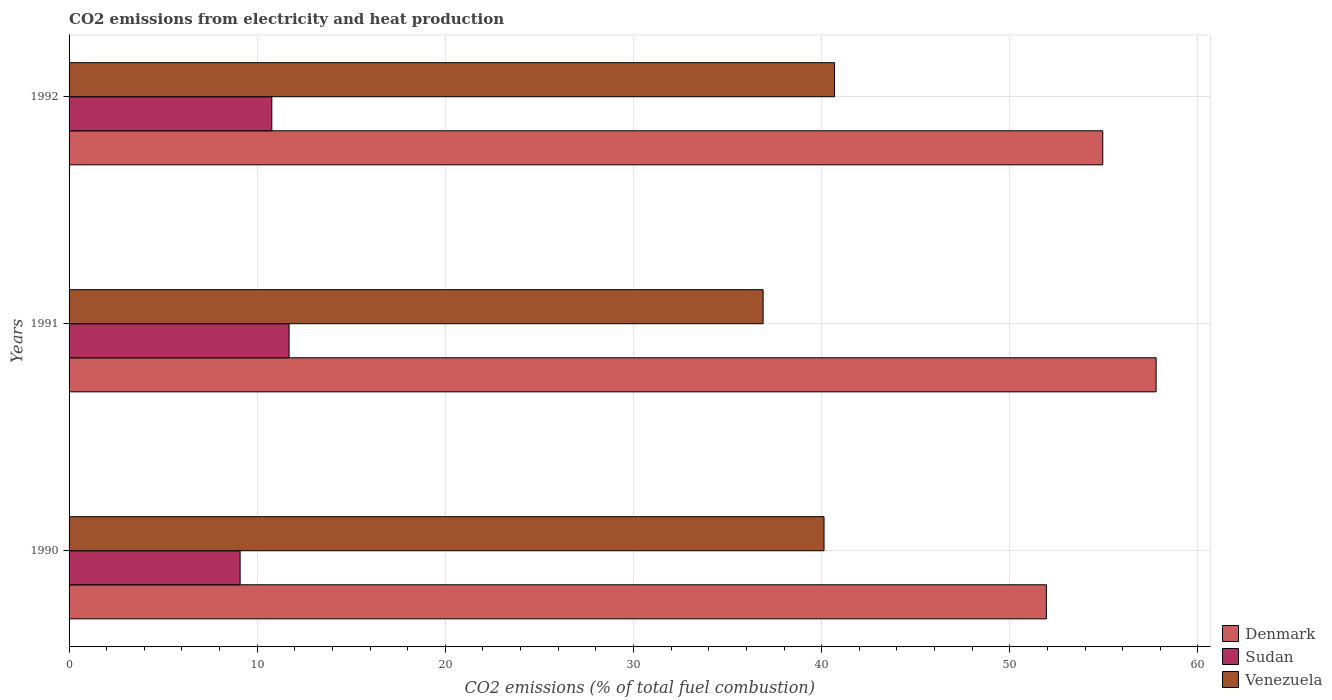How many different coloured bars are there?
Your answer should be very brief. 3. How many groups of bars are there?
Ensure brevity in your answer.  3. Are the number of bars per tick equal to the number of legend labels?
Your answer should be very brief. Yes. How many bars are there on the 3rd tick from the top?
Make the answer very short. 3. What is the label of the 3rd group of bars from the top?
Keep it short and to the point. 1990. In how many cases, is the number of bars for a given year not equal to the number of legend labels?
Your answer should be compact. 0. What is the amount of CO2 emitted in Sudan in 1992?
Make the answer very short. 10.78. Across all years, what is the maximum amount of CO2 emitted in Denmark?
Give a very brief answer. 57.78. Across all years, what is the minimum amount of CO2 emitted in Sudan?
Your answer should be very brief. 9.09. What is the total amount of CO2 emitted in Denmark in the graph?
Your response must be concise. 164.67. What is the difference between the amount of CO2 emitted in Venezuela in 1990 and that in 1992?
Your answer should be very brief. -0.56. What is the difference between the amount of CO2 emitted in Denmark in 1990 and the amount of CO2 emitted in Venezuela in 1991?
Provide a short and direct response. 15.06. What is the average amount of CO2 emitted in Sudan per year?
Make the answer very short. 10.52. In the year 1991, what is the difference between the amount of CO2 emitted in Denmark and amount of CO2 emitted in Sudan?
Ensure brevity in your answer.  46.08. In how many years, is the amount of CO2 emitted in Venezuela greater than 22 %?
Keep it short and to the point. 3. What is the ratio of the amount of CO2 emitted in Venezuela in 1990 to that in 1992?
Offer a very short reply. 0.99. Is the amount of CO2 emitted in Denmark in 1990 less than that in 1992?
Offer a very short reply. Yes. Is the difference between the amount of CO2 emitted in Denmark in 1990 and 1991 greater than the difference between the amount of CO2 emitted in Sudan in 1990 and 1991?
Provide a succinct answer. No. What is the difference between the highest and the second highest amount of CO2 emitted in Venezuela?
Provide a short and direct response. 0.56. What is the difference between the highest and the lowest amount of CO2 emitted in Venezuela?
Your answer should be compact. 3.8. In how many years, is the amount of CO2 emitted in Venezuela greater than the average amount of CO2 emitted in Venezuela taken over all years?
Your response must be concise. 2. What does the 2nd bar from the top in 1992 represents?
Provide a succinct answer. Sudan. How many years are there in the graph?
Provide a succinct answer. 3. Does the graph contain any zero values?
Your answer should be very brief. No. Does the graph contain grids?
Ensure brevity in your answer.  Yes. How many legend labels are there?
Keep it short and to the point. 3. What is the title of the graph?
Ensure brevity in your answer.  CO2 emissions from electricity and heat production. Does "Congo (Democratic)" appear as one of the legend labels in the graph?
Give a very brief answer. No. What is the label or title of the X-axis?
Ensure brevity in your answer.  CO2 emissions (% of total fuel combustion). What is the CO2 emissions (% of total fuel combustion) of Denmark in 1990?
Make the answer very short. 51.95. What is the CO2 emissions (% of total fuel combustion) of Sudan in 1990?
Your answer should be compact. 9.09. What is the CO2 emissions (% of total fuel combustion) of Venezuela in 1990?
Provide a succinct answer. 40.13. What is the CO2 emissions (% of total fuel combustion) of Denmark in 1991?
Your answer should be very brief. 57.78. What is the CO2 emissions (% of total fuel combustion) in Sudan in 1991?
Ensure brevity in your answer.  11.69. What is the CO2 emissions (% of total fuel combustion) in Venezuela in 1991?
Provide a succinct answer. 36.89. What is the CO2 emissions (% of total fuel combustion) of Denmark in 1992?
Your answer should be compact. 54.94. What is the CO2 emissions (% of total fuel combustion) in Sudan in 1992?
Your answer should be compact. 10.78. What is the CO2 emissions (% of total fuel combustion) of Venezuela in 1992?
Give a very brief answer. 40.69. Across all years, what is the maximum CO2 emissions (% of total fuel combustion) of Denmark?
Make the answer very short. 57.78. Across all years, what is the maximum CO2 emissions (% of total fuel combustion) in Sudan?
Ensure brevity in your answer.  11.69. Across all years, what is the maximum CO2 emissions (% of total fuel combustion) in Venezuela?
Your answer should be very brief. 40.69. Across all years, what is the minimum CO2 emissions (% of total fuel combustion) of Denmark?
Offer a terse response. 51.95. Across all years, what is the minimum CO2 emissions (% of total fuel combustion) in Sudan?
Your answer should be compact. 9.09. Across all years, what is the minimum CO2 emissions (% of total fuel combustion) of Venezuela?
Your response must be concise. 36.89. What is the total CO2 emissions (% of total fuel combustion) of Denmark in the graph?
Make the answer very short. 164.67. What is the total CO2 emissions (% of total fuel combustion) in Sudan in the graph?
Make the answer very short. 31.56. What is the total CO2 emissions (% of total fuel combustion) in Venezuela in the graph?
Provide a succinct answer. 117.7. What is the difference between the CO2 emissions (% of total fuel combustion) of Denmark in 1990 and that in 1991?
Your answer should be very brief. -5.83. What is the difference between the CO2 emissions (% of total fuel combustion) of Sudan in 1990 and that in 1991?
Give a very brief answer. -2.6. What is the difference between the CO2 emissions (% of total fuel combustion) in Venezuela in 1990 and that in 1991?
Your answer should be compact. 3.24. What is the difference between the CO2 emissions (% of total fuel combustion) in Denmark in 1990 and that in 1992?
Provide a succinct answer. -3. What is the difference between the CO2 emissions (% of total fuel combustion) of Sudan in 1990 and that in 1992?
Your answer should be very brief. -1.69. What is the difference between the CO2 emissions (% of total fuel combustion) of Venezuela in 1990 and that in 1992?
Make the answer very short. -0.56. What is the difference between the CO2 emissions (% of total fuel combustion) in Denmark in 1991 and that in 1992?
Give a very brief answer. 2.84. What is the difference between the CO2 emissions (% of total fuel combustion) of Sudan in 1991 and that in 1992?
Your answer should be very brief. 0.92. What is the difference between the CO2 emissions (% of total fuel combustion) in Venezuela in 1991 and that in 1992?
Your answer should be very brief. -3.8. What is the difference between the CO2 emissions (% of total fuel combustion) in Denmark in 1990 and the CO2 emissions (% of total fuel combustion) in Sudan in 1991?
Give a very brief answer. 40.25. What is the difference between the CO2 emissions (% of total fuel combustion) in Denmark in 1990 and the CO2 emissions (% of total fuel combustion) in Venezuela in 1991?
Your answer should be compact. 15.06. What is the difference between the CO2 emissions (% of total fuel combustion) in Sudan in 1990 and the CO2 emissions (% of total fuel combustion) in Venezuela in 1991?
Offer a terse response. -27.8. What is the difference between the CO2 emissions (% of total fuel combustion) of Denmark in 1990 and the CO2 emissions (% of total fuel combustion) of Sudan in 1992?
Provide a short and direct response. 41.17. What is the difference between the CO2 emissions (% of total fuel combustion) in Denmark in 1990 and the CO2 emissions (% of total fuel combustion) in Venezuela in 1992?
Your answer should be compact. 11.26. What is the difference between the CO2 emissions (% of total fuel combustion) in Sudan in 1990 and the CO2 emissions (% of total fuel combustion) in Venezuela in 1992?
Provide a succinct answer. -31.6. What is the difference between the CO2 emissions (% of total fuel combustion) in Denmark in 1991 and the CO2 emissions (% of total fuel combustion) in Sudan in 1992?
Your answer should be very brief. 47. What is the difference between the CO2 emissions (% of total fuel combustion) in Denmark in 1991 and the CO2 emissions (% of total fuel combustion) in Venezuela in 1992?
Ensure brevity in your answer.  17.09. What is the difference between the CO2 emissions (% of total fuel combustion) in Sudan in 1991 and the CO2 emissions (% of total fuel combustion) in Venezuela in 1992?
Provide a succinct answer. -28.99. What is the average CO2 emissions (% of total fuel combustion) in Denmark per year?
Your answer should be very brief. 54.89. What is the average CO2 emissions (% of total fuel combustion) in Sudan per year?
Your answer should be compact. 10.52. What is the average CO2 emissions (% of total fuel combustion) of Venezuela per year?
Your response must be concise. 39.23. In the year 1990, what is the difference between the CO2 emissions (% of total fuel combustion) in Denmark and CO2 emissions (% of total fuel combustion) in Sudan?
Give a very brief answer. 42.85. In the year 1990, what is the difference between the CO2 emissions (% of total fuel combustion) of Denmark and CO2 emissions (% of total fuel combustion) of Venezuela?
Offer a very short reply. 11.82. In the year 1990, what is the difference between the CO2 emissions (% of total fuel combustion) in Sudan and CO2 emissions (% of total fuel combustion) in Venezuela?
Keep it short and to the point. -31.04. In the year 1991, what is the difference between the CO2 emissions (% of total fuel combustion) in Denmark and CO2 emissions (% of total fuel combustion) in Sudan?
Make the answer very short. 46.09. In the year 1991, what is the difference between the CO2 emissions (% of total fuel combustion) in Denmark and CO2 emissions (% of total fuel combustion) in Venezuela?
Offer a terse response. 20.89. In the year 1991, what is the difference between the CO2 emissions (% of total fuel combustion) of Sudan and CO2 emissions (% of total fuel combustion) of Venezuela?
Provide a succinct answer. -25.2. In the year 1992, what is the difference between the CO2 emissions (% of total fuel combustion) in Denmark and CO2 emissions (% of total fuel combustion) in Sudan?
Ensure brevity in your answer.  44.17. In the year 1992, what is the difference between the CO2 emissions (% of total fuel combustion) of Denmark and CO2 emissions (% of total fuel combustion) of Venezuela?
Your answer should be very brief. 14.26. In the year 1992, what is the difference between the CO2 emissions (% of total fuel combustion) in Sudan and CO2 emissions (% of total fuel combustion) in Venezuela?
Make the answer very short. -29.91. What is the ratio of the CO2 emissions (% of total fuel combustion) of Denmark in 1990 to that in 1991?
Offer a terse response. 0.9. What is the ratio of the CO2 emissions (% of total fuel combustion) in Sudan in 1990 to that in 1991?
Your answer should be compact. 0.78. What is the ratio of the CO2 emissions (% of total fuel combustion) of Venezuela in 1990 to that in 1991?
Ensure brevity in your answer.  1.09. What is the ratio of the CO2 emissions (% of total fuel combustion) in Denmark in 1990 to that in 1992?
Your answer should be compact. 0.95. What is the ratio of the CO2 emissions (% of total fuel combustion) in Sudan in 1990 to that in 1992?
Ensure brevity in your answer.  0.84. What is the ratio of the CO2 emissions (% of total fuel combustion) of Venezuela in 1990 to that in 1992?
Make the answer very short. 0.99. What is the ratio of the CO2 emissions (% of total fuel combustion) of Denmark in 1991 to that in 1992?
Your answer should be compact. 1.05. What is the ratio of the CO2 emissions (% of total fuel combustion) of Sudan in 1991 to that in 1992?
Provide a short and direct response. 1.09. What is the ratio of the CO2 emissions (% of total fuel combustion) in Venezuela in 1991 to that in 1992?
Give a very brief answer. 0.91. What is the difference between the highest and the second highest CO2 emissions (% of total fuel combustion) in Denmark?
Give a very brief answer. 2.84. What is the difference between the highest and the second highest CO2 emissions (% of total fuel combustion) of Sudan?
Provide a succinct answer. 0.92. What is the difference between the highest and the second highest CO2 emissions (% of total fuel combustion) in Venezuela?
Provide a succinct answer. 0.56. What is the difference between the highest and the lowest CO2 emissions (% of total fuel combustion) of Denmark?
Provide a succinct answer. 5.83. What is the difference between the highest and the lowest CO2 emissions (% of total fuel combustion) of Sudan?
Offer a very short reply. 2.6. What is the difference between the highest and the lowest CO2 emissions (% of total fuel combustion) in Venezuela?
Ensure brevity in your answer.  3.8. 